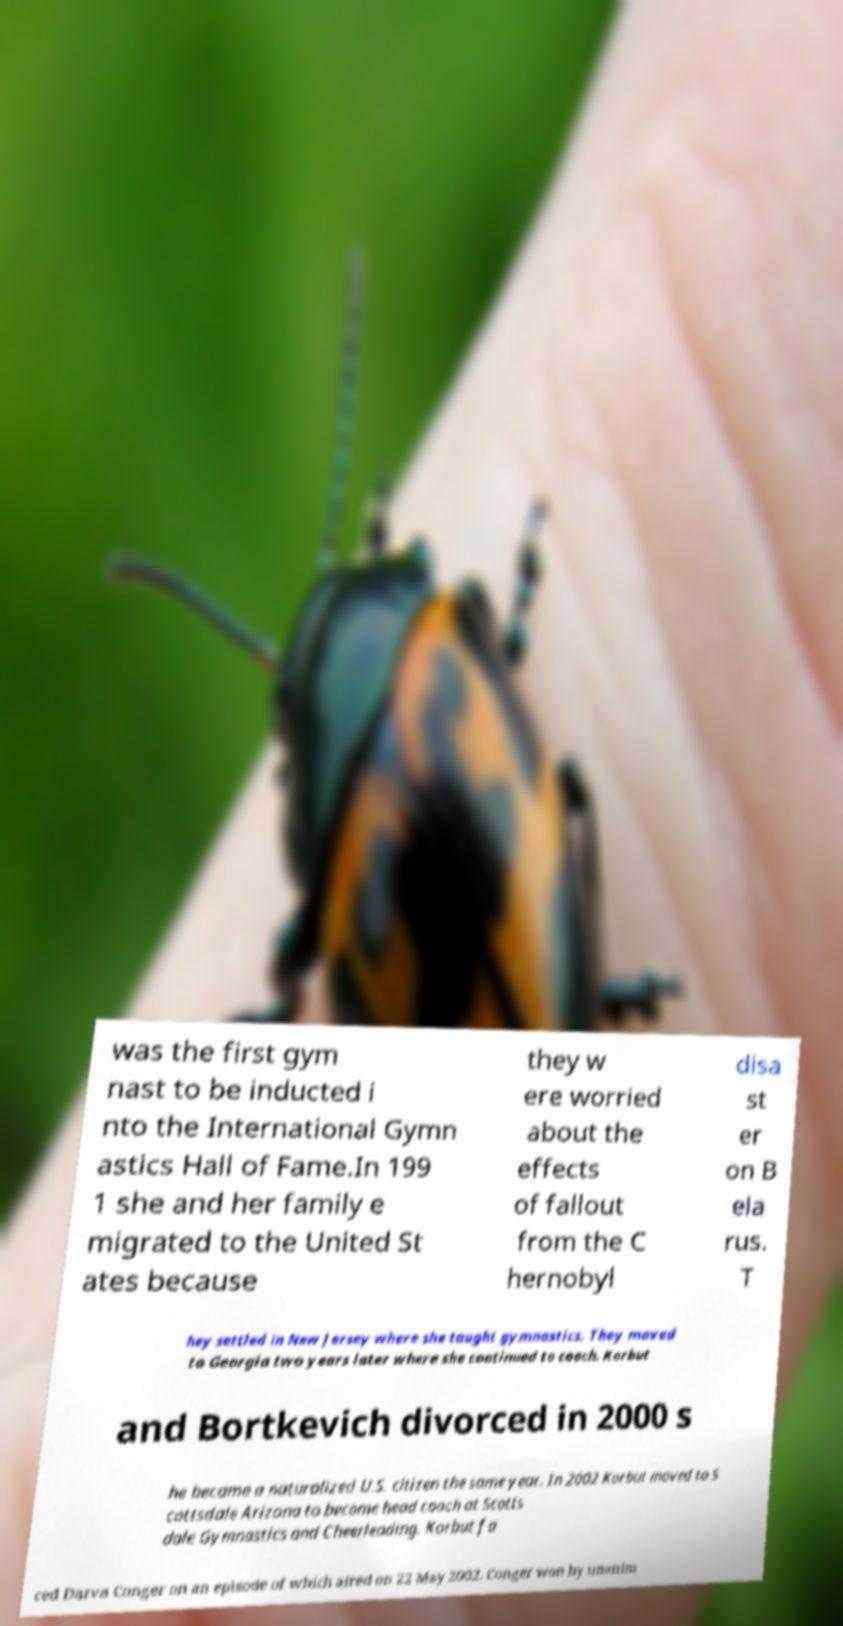What messages or text are displayed in this image? I need them in a readable, typed format. was the first gym nast to be inducted i nto the International Gymn astics Hall of Fame.In 199 1 she and her family e migrated to the United St ates because they w ere worried about the effects of fallout from the C hernobyl disa st er on B ela rus. T hey settled in New Jersey where she taught gymnastics. They moved to Georgia two years later where she continued to coach. Korbut and Bortkevich divorced in 2000 s he became a naturalized U.S. citizen the same year. In 2002 Korbut moved to S cottsdale Arizona to become head coach at Scotts dale Gymnastics and Cheerleading. Korbut fa ced Darva Conger on an episode of which aired on 22 May 2002. Conger won by unanim 